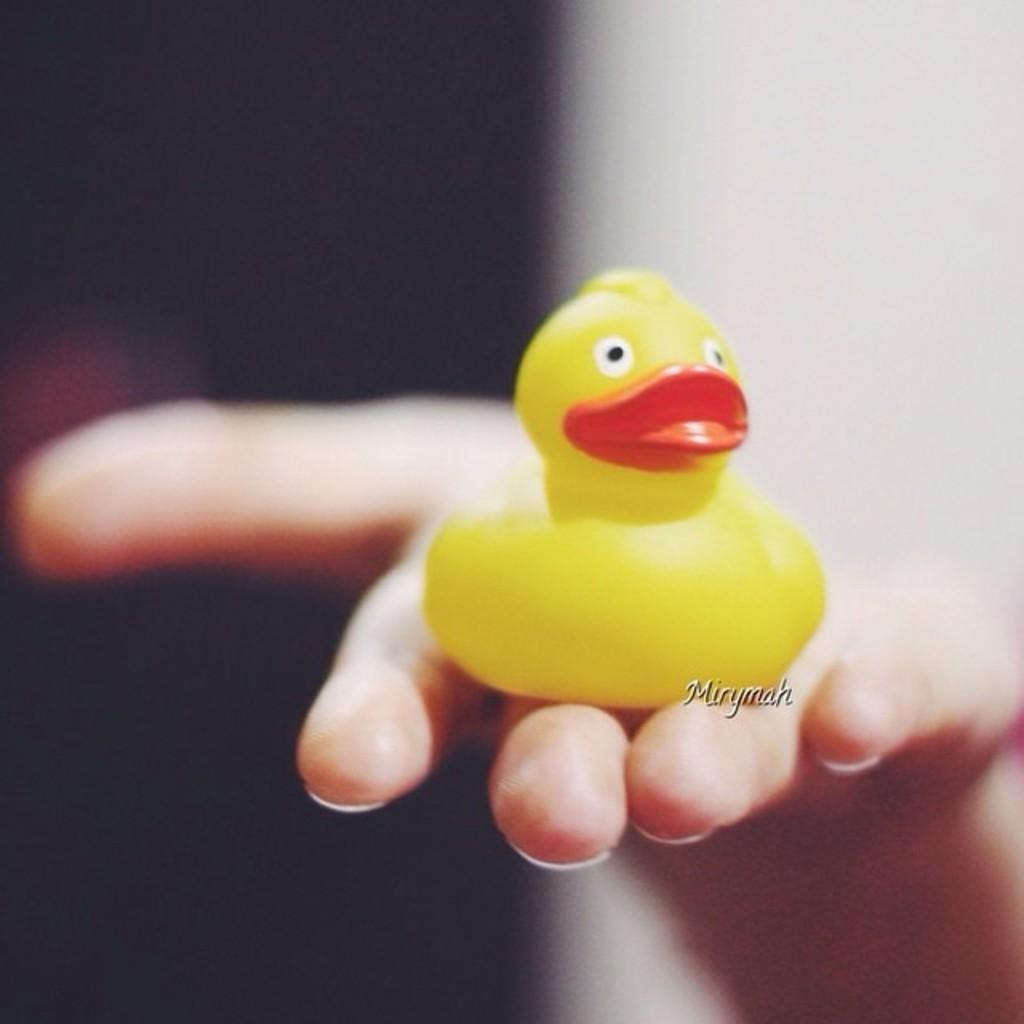Describe this image in one or two sentences. In this picture there is a toy on the hand of the person which is visible in the center and the background is blurry. 